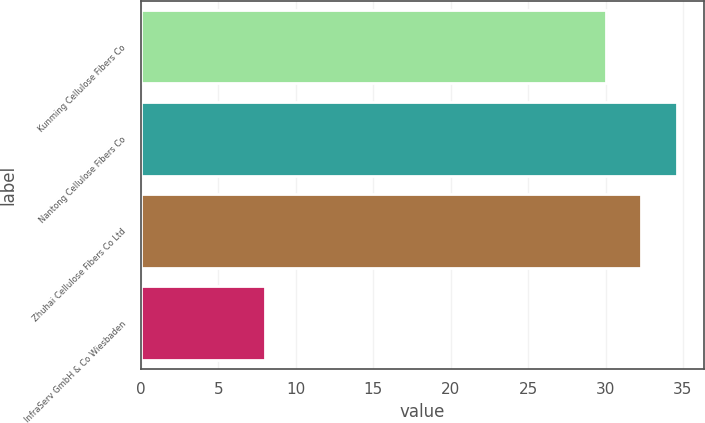Convert chart. <chart><loc_0><loc_0><loc_500><loc_500><bar_chart><fcel>Kunming Cellulose Fibers Co<fcel>Nantong Cellulose Fibers Co<fcel>Zhuhai Cellulose Fibers Co Ltd<fcel>InfraServ GmbH & Co Wiesbaden<nl><fcel>30<fcel>34.6<fcel>32.3<fcel>8<nl></chart> 